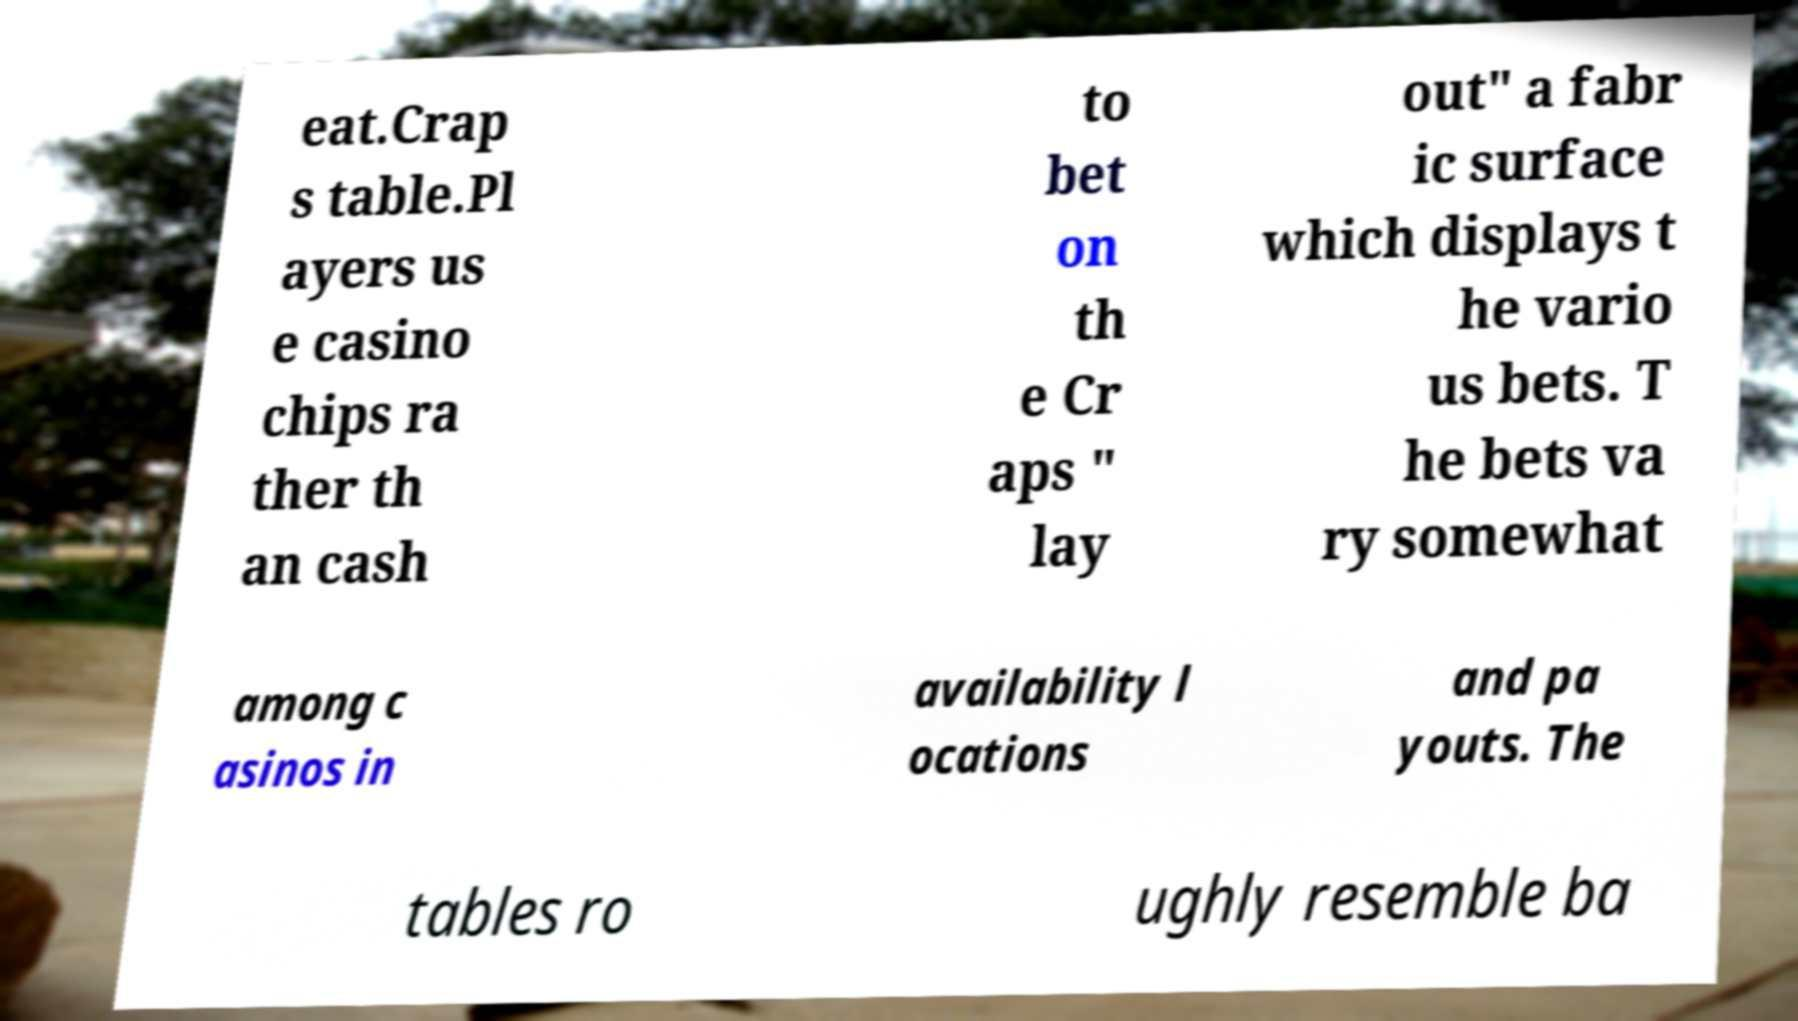Can you read and provide the text displayed in the image?This photo seems to have some interesting text. Can you extract and type it out for me? eat.Crap s table.Pl ayers us e casino chips ra ther th an cash to bet on th e Cr aps " lay out" a fabr ic surface which displays t he vario us bets. T he bets va ry somewhat among c asinos in availability l ocations and pa youts. The tables ro ughly resemble ba 